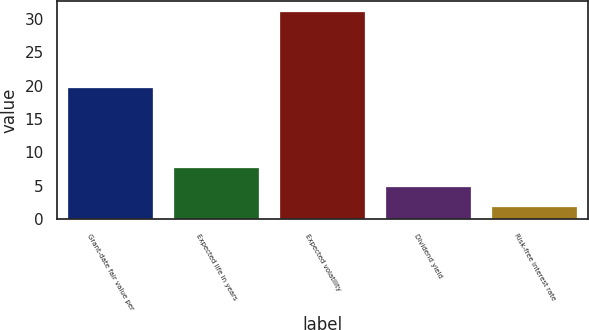<chart> <loc_0><loc_0><loc_500><loc_500><bar_chart><fcel>Grant-date fair value per<fcel>Expected life in years<fcel>Expected volatility<fcel>Dividend yield<fcel>Risk-free interest rate<nl><fcel>19.56<fcel>7.72<fcel>31<fcel>4.81<fcel>1.9<nl></chart> 